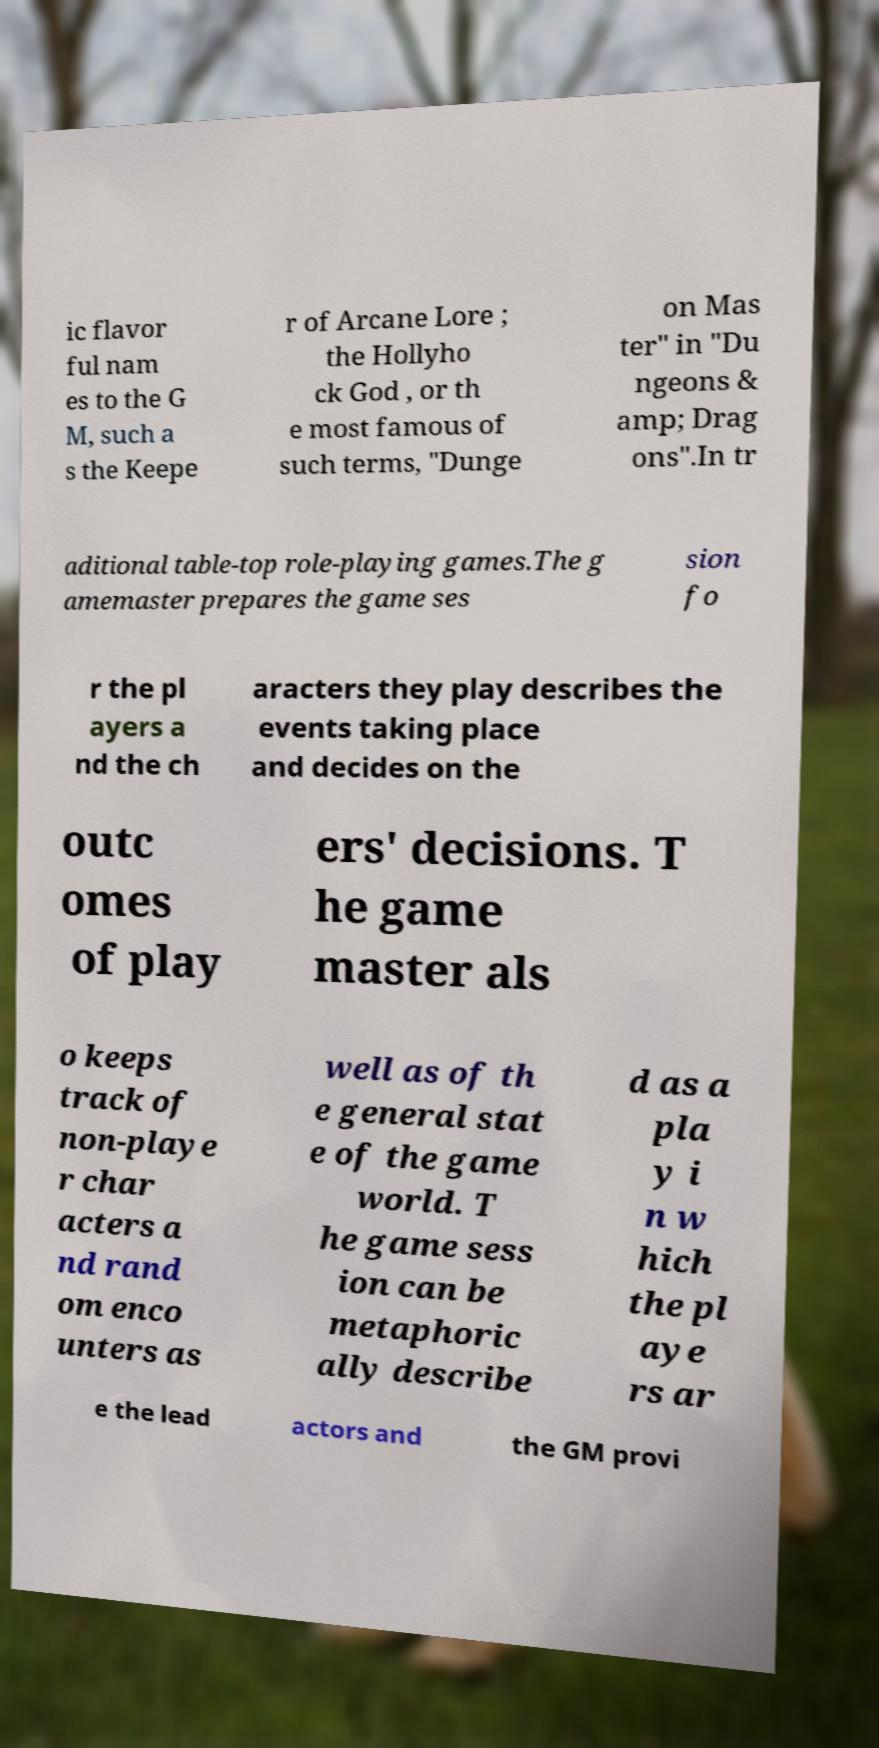Can you read and provide the text displayed in the image?This photo seems to have some interesting text. Can you extract and type it out for me? ic flavor ful nam es to the G M, such a s the Keepe r of Arcane Lore ; the Hollyho ck God , or th e most famous of such terms, "Dunge on Mas ter" in "Du ngeons & amp; Drag ons".In tr aditional table-top role-playing games.The g amemaster prepares the game ses sion fo r the pl ayers a nd the ch aracters they play describes the events taking place and decides on the outc omes of play ers' decisions. T he game master als o keeps track of non-playe r char acters a nd rand om enco unters as well as of th e general stat e of the game world. T he game sess ion can be metaphoric ally describe d as a pla y i n w hich the pl aye rs ar e the lead actors and the GM provi 